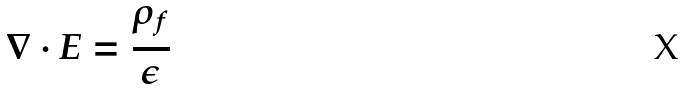Convert formula to latex. <formula><loc_0><loc_0><loc_500><loc_500>\nabla \cdot E = \frac { \rho _ { f } } { \epsilon }</formula> 